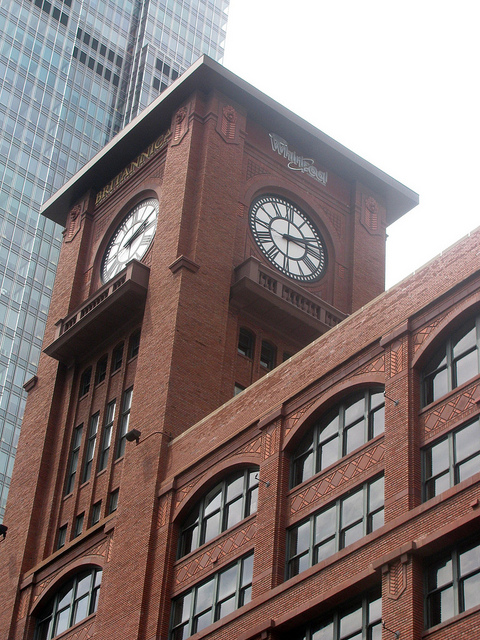<image>What the written above the clock? I don't know what is written above the clock. It could be either 'whirlpool' , ' time' , 'west pool' or 'windsor'. What do the letters say on the tower? I am not sure what the letters say on the tower, but it might be 'whirlpool'. What the written above the clock? I am not sure what is written above the clock. It can be seen as 'whirlpool' or 'time'. What do the letters say on the tower? I don't know what the letters say on the tower. It could be 'whirlpool' or it could be something else. 